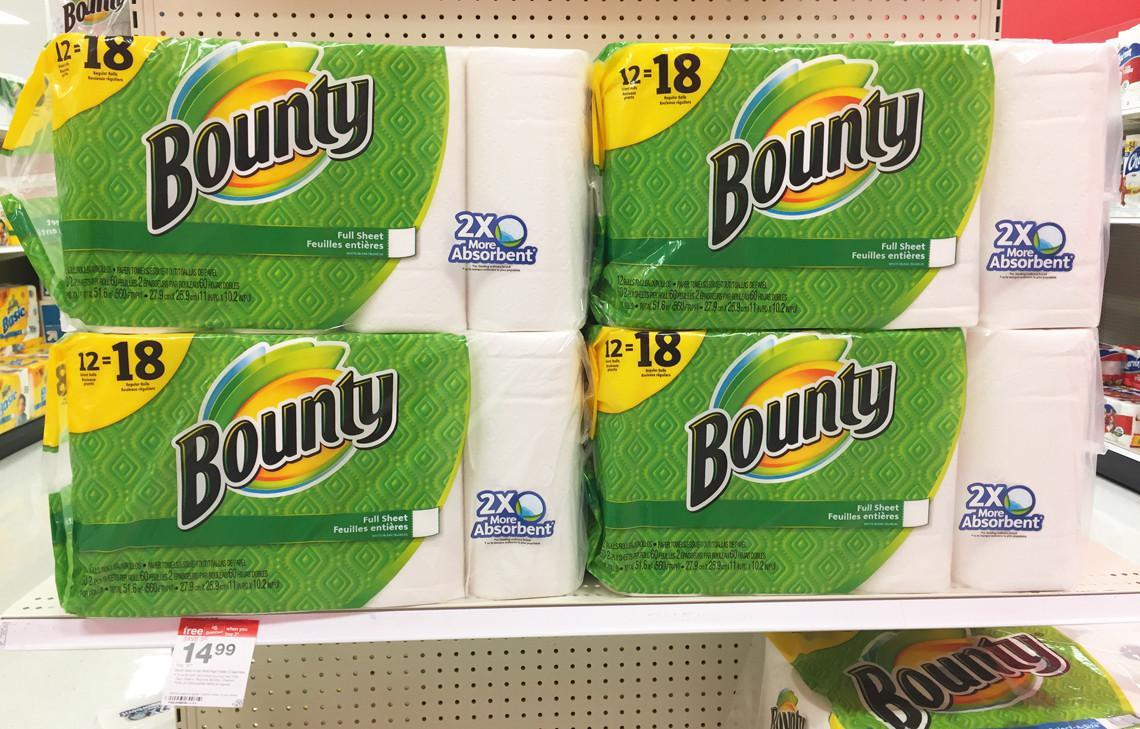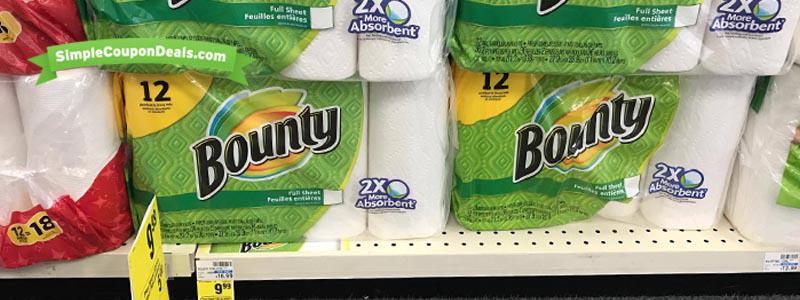The first image is the image on the left, the second image is the image on the right. Considering the images on both sides, is "Each image shows multipack paper towels in green and yellow packaging on store shelves with white pegboard." valid? Answer yes or no. Yes. 